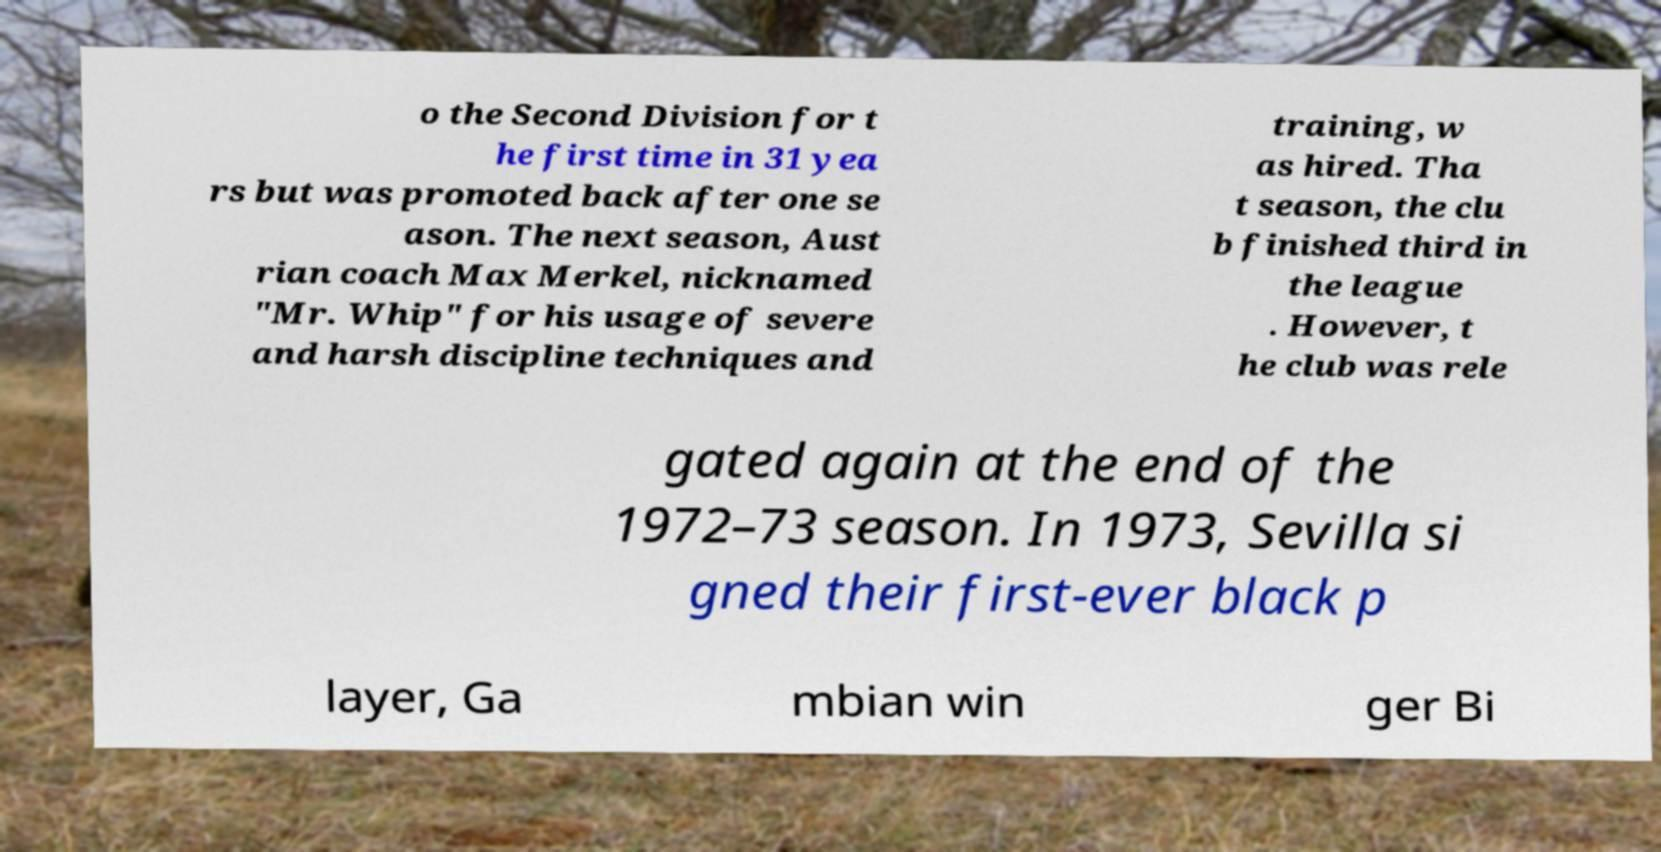Can you read and provide the text displayed in the image?This photo seems to have some interesting text. Can you extract and type it out for me? o the Second Division for t he first time in 31 yea rs but was promoted back after one se ason. The next season, Aust rian coach Max Merkel, nicknamed "Mr. Whip" for his usage of severe and harsh discipline techniques and training, w as hired. Tha t season, the clu b finished third in the league . However, t he club was rele gated again at the end of the 1972–73 season. In 1973, Sevilla si gned their first-ever black p layer, Ga mbian win ger Bi 